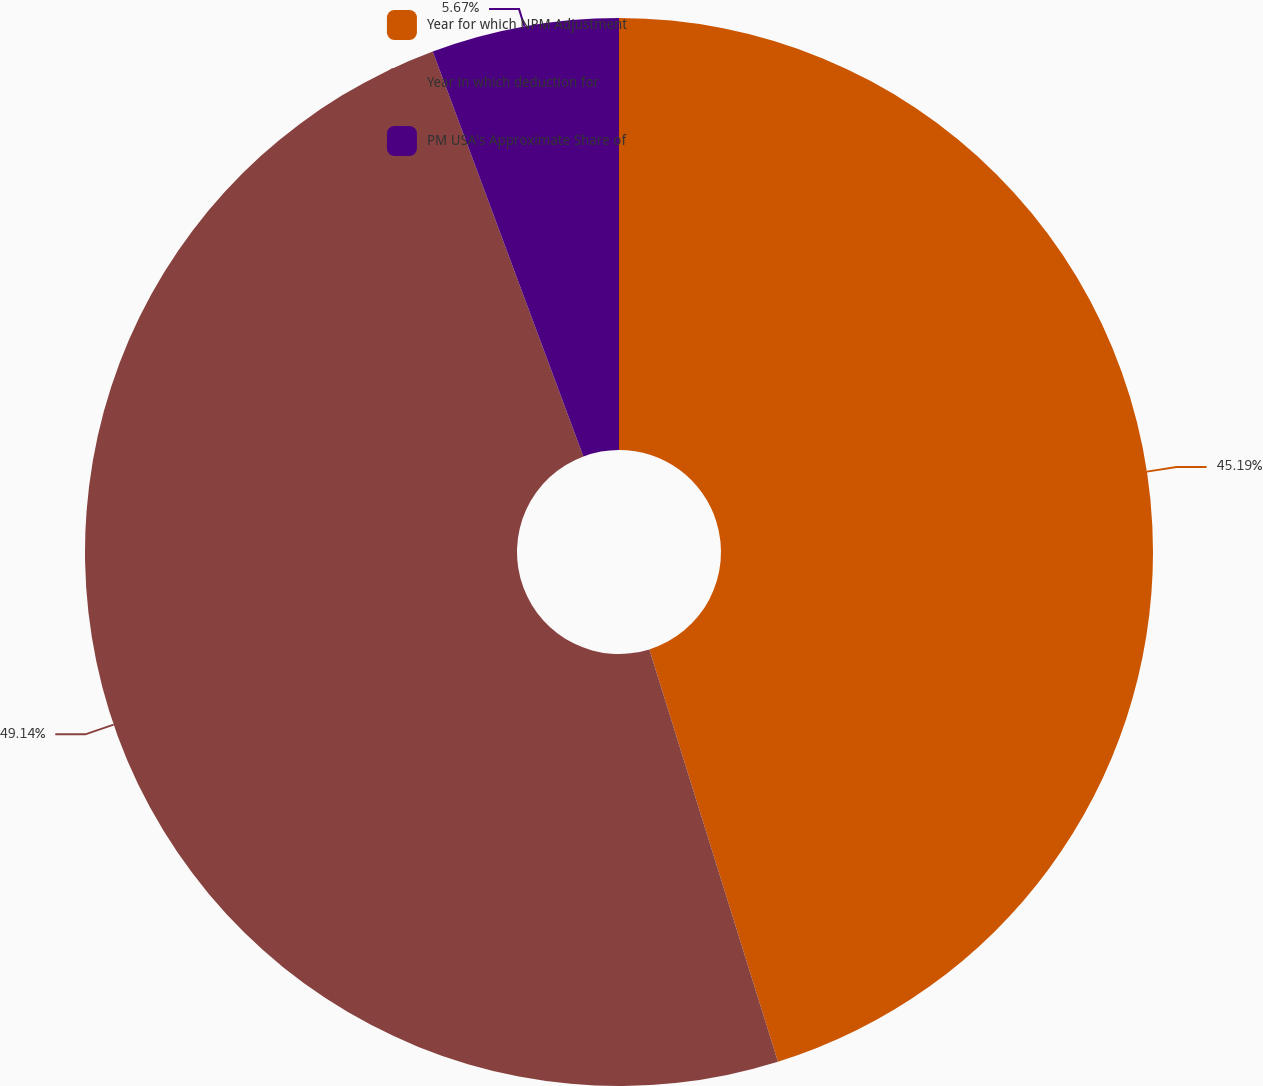Convert chart to OTSL. <chart><loc_0><loc_0><loc_500><loc_500><pie_chart><fcel>Year for which NPM Adjustment<fcel>Year in which deduction for<fcel>PM USA's Approximate Share of<nl><fcel>45.19%<fcel>49.14%<fcel>5.67%<nl></chart> 